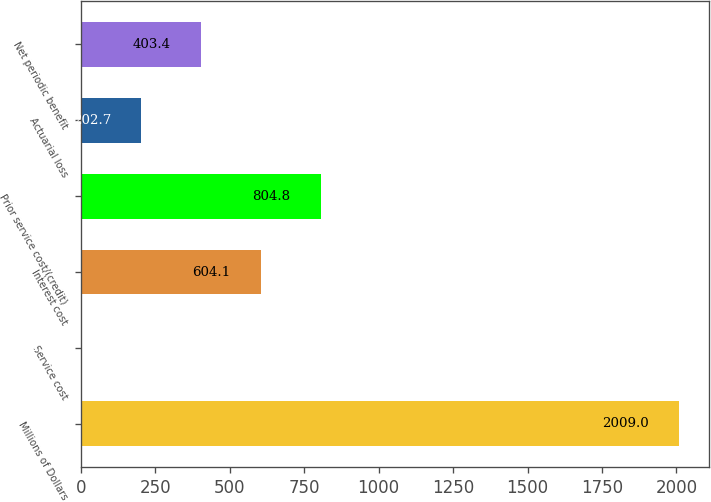Convert chart. <chart><loc_0><loc_0><loc_500><loc_500><bar_chart><fcel>Millions of Dollars<fcel>Service cost<fcel>Interest cost<fcel>Prior service cost/(credit)<fcel>Actuarial loss<fcel>Net periodic benefit<nl><fcel>2009<fcel>2<fcel>604.1<fcel>804.8<fcel>202.7<fcel>403.4<nl></chart> 